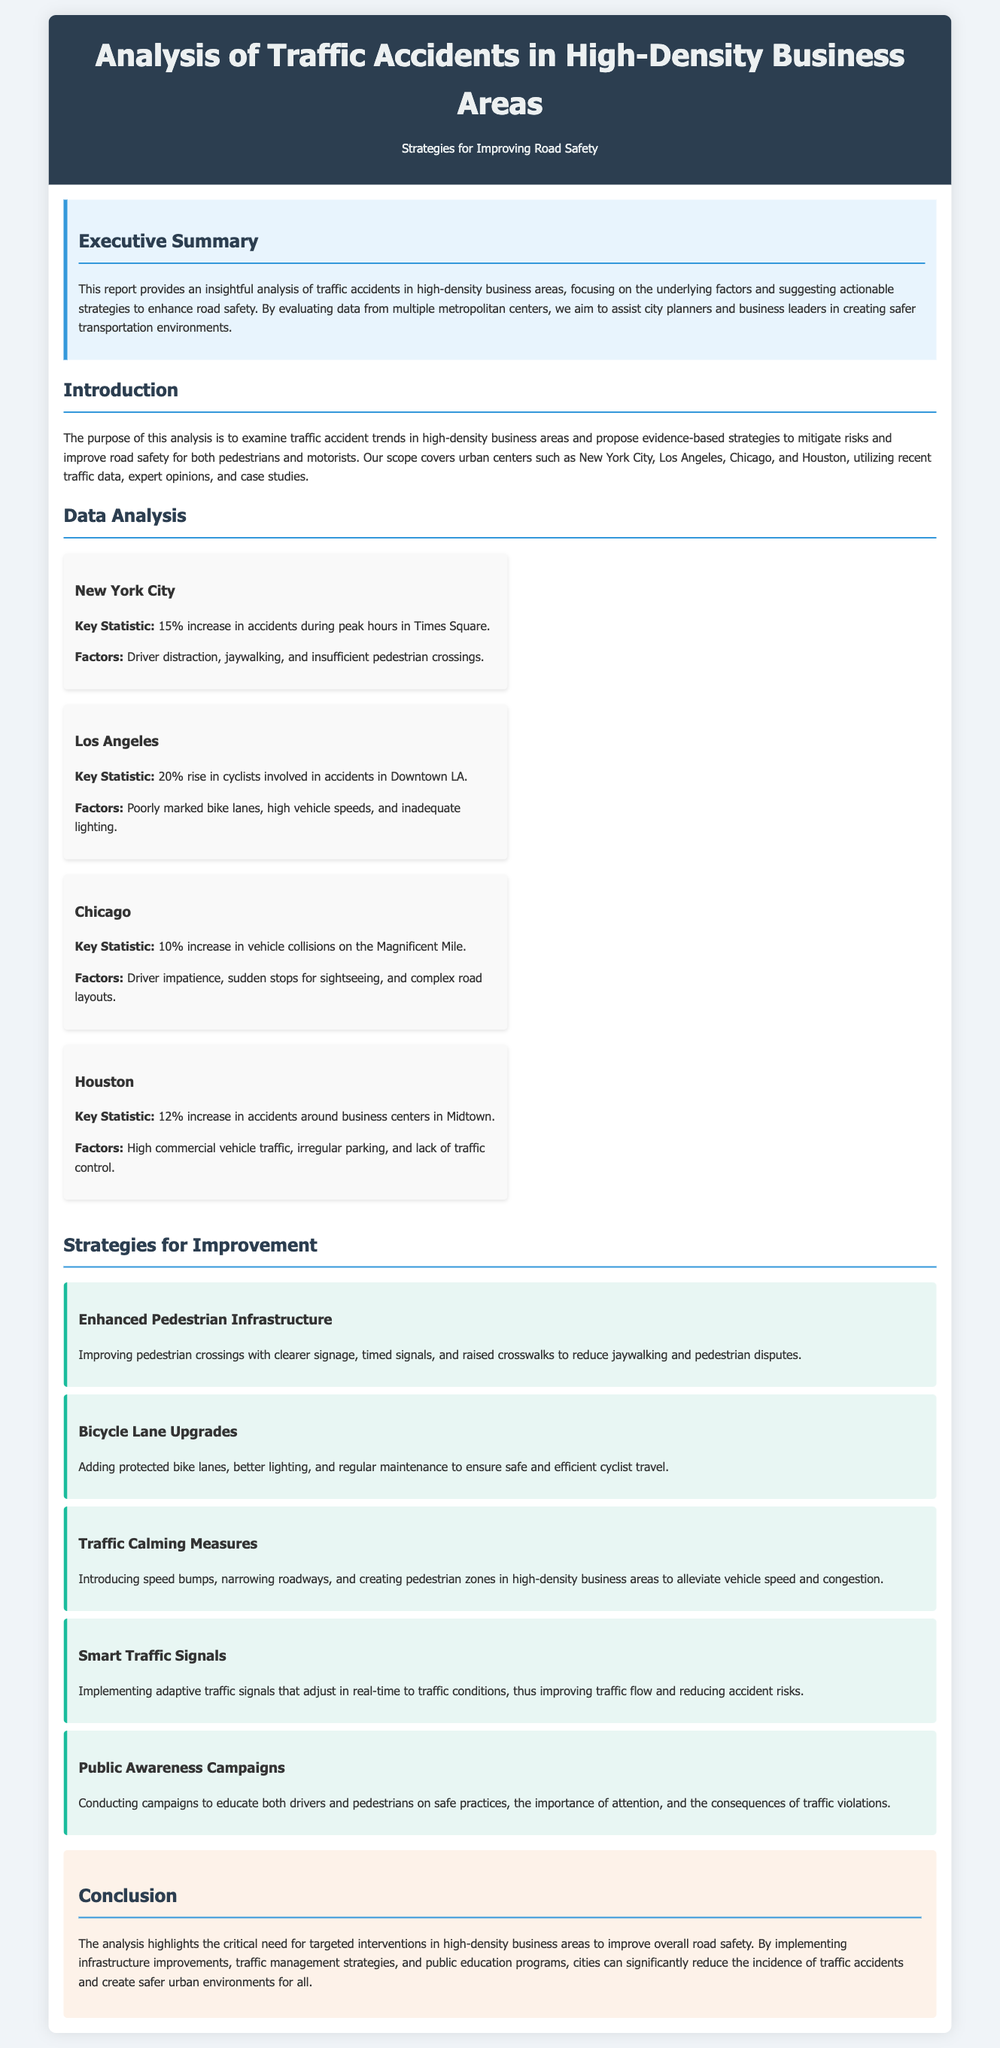What was the percentage increase in accidents during peak hours in Times Square? The report states that there was a 15% increase in accidents during peak hours in Times Square.
Answer: 15% What key factors contributed to traffic accidents in Downtown LA? The factors listed include poorly marked bike lanes, high vehicle speeds, and inadequate lighting.
Answer: Poorly marked bike lanes, high vehicle speeds, and inadequate lighting Which city experienced a 10% increase in vehicle collisions on the Magnificent Mile? The document indicates that Chicago had a 10% increase in vehicle collisions on the Magnificent Mile.
Answer: Chicago What is one strategy for enhancing pedestrian infrastructure? The report suggests improving pedestrian crossings with clearer signage, timed signals, and raised crosswalks.
Answer: Improving pedestrian crossings with clearer signage, timed signals, and raised crosswalks What percentage increase in accidents was reported around business centers in Midtown, Houston? The report mentions a 12% increase in accidents around business centers in Midtown, Houston.
Answer: 12% What is the purpose of implementing smart traffic signals according to the report? Smart traffic signals are intended to adjust in real-time to traffic conditions, improving traffic flow and reducing accident risks.
Answer: Adjust in real-time to traffic conditions What is one key recommendation for cyclists in the strategies section? The document recommends adding protected bike lanes, better lighting, and regular maintenance to ensure safe and efficient cyclist travel.
Answer: Adding protected bike lanes, better lighting, and regular maintenance Which urban center is specifically mentioned in relation to driver impatience as a contributing factor? The city mentioned is Chicago, where driver impatience is noted as a contributing factor.
Answer: Chicago What overall conclusion is drawn from the analysis regarding road safety? The analysis concludes that targeted interventions are needed to improve overall road safety in high-density business areas.
Answer: Targeted interventions are needed to improve overall road safety 